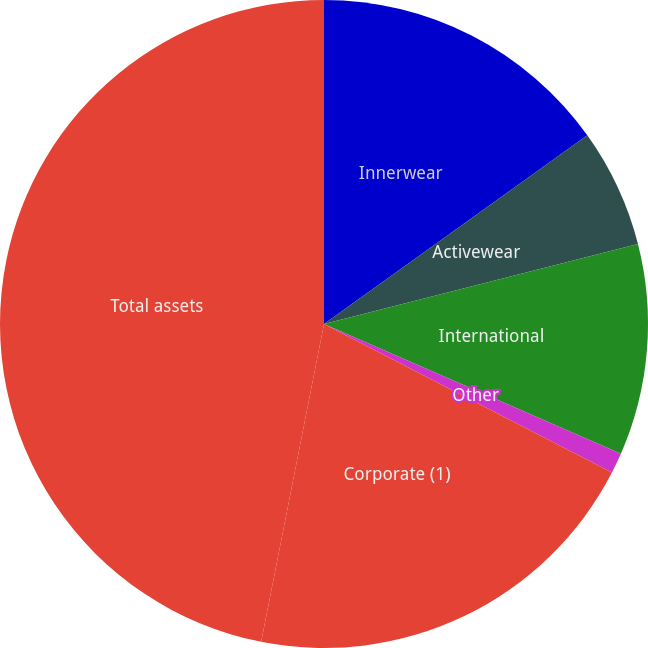Convert chart. <chart><loc_0><loc_0><loc_500><loc_500><pie_chart><fcel>Innerwear<fcel>Activewear<fcel>International<fcel>Other<fcel>Corporate (1)<fcel>Total assets<nl><fcel>15.1%<fcel>5.93%<fcel>10.52%<fcel>1.03%<fcel>20.52%<fcel>46.89%<nl></chart> 